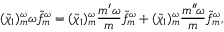<formula> <loc_0><loc_0><loc_500><loc_500>( \widetilde { \chi } _ { 1 } ) _ { m } ^ { \omega } \omega \widetilde { f } _ { m } ^ { \omega } = ( \widetilde { \chi } _ { 1 } ) _ { m } ^ { \omega } \frac { m ^ { \prime } \omega } { m } \widetilde { f } _ { m } ^ { \omega } + ( \widetilde { \chi } _ { 1 } ) _ { m } ^ { \omega } \frac { m ^ { \prime \prime } \, \omega } { m } \widetilde { f } _ { m } ^ { \omega } ,</formula> 